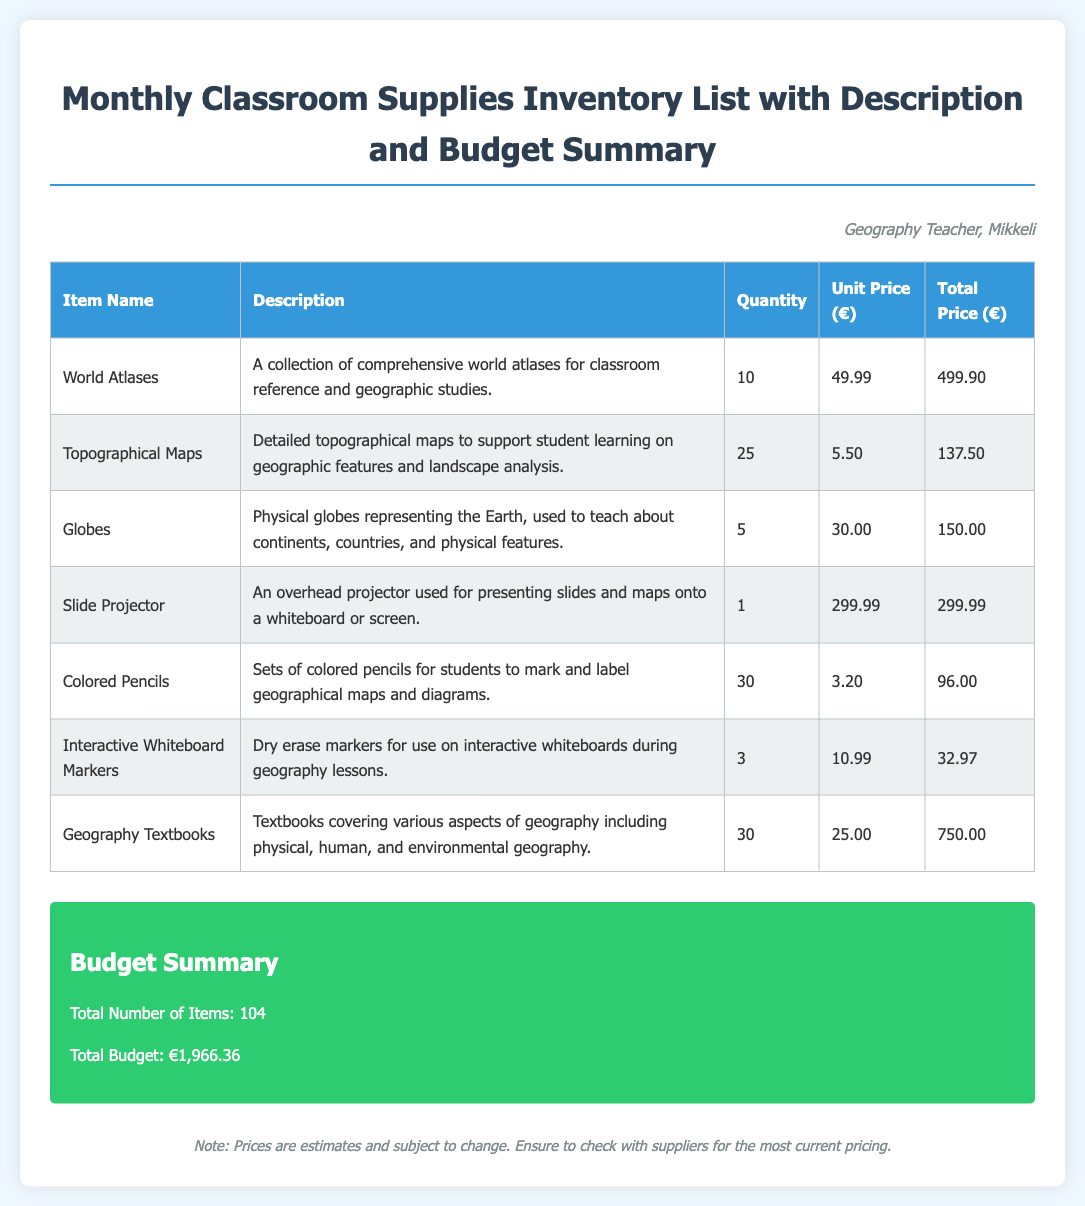what is the total budget? The total budget is listed in the document as €1,966.36.
Answer: €1,966.36 how many World Atlases are there? The document specifies that there are 10 World Atlases.
Answer: 10 what is the unit price of the Geography Textbooks? The unit price for Geography Textbooks is €25.00 as stated in the document.
Answer: €25.00 which item has the highest total price? The item with the highest total price is the Geography Textbooks totaling €750.00.
Answer: Geography Textbooks how many items are listed in total? The document indicates and summarizes a total of 104 items listed.
Answer: 104 what is the description of the Slide Projector? The description of the Slide Projector is provided as an overhead projector used for presenting slides and maps onto a whiteboard or screen.
Answer: An overhead projector used for presenting slides and maps onto a whiteboard or screen which supply is intended for marking geographical maps? The Colored Pencils are specifically intended for marking geographical maps.
Answer: Colored Pencils what is the total price of the Topographical Maps? The total price for the Topographical Maps is specified as €137.50.
Answer: €137.50 